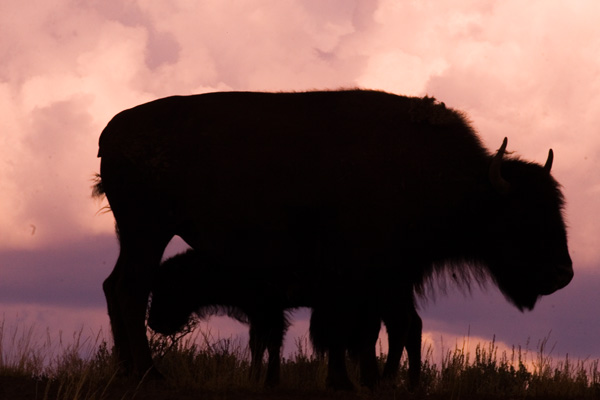Can you tell what type of animal is in the image? The outline of the animal with its distinctive hump and horns suggests it's a bison, often seen in such profiles against open landscapes. 